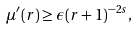Convert formula to latex. <formula><loc_0><loc_0><loc_500><loc_500>\mu ^ { \prime } ( r ) \geq \epsilon ( r + 1 ) ^ { - 2 s } ,</formula> 